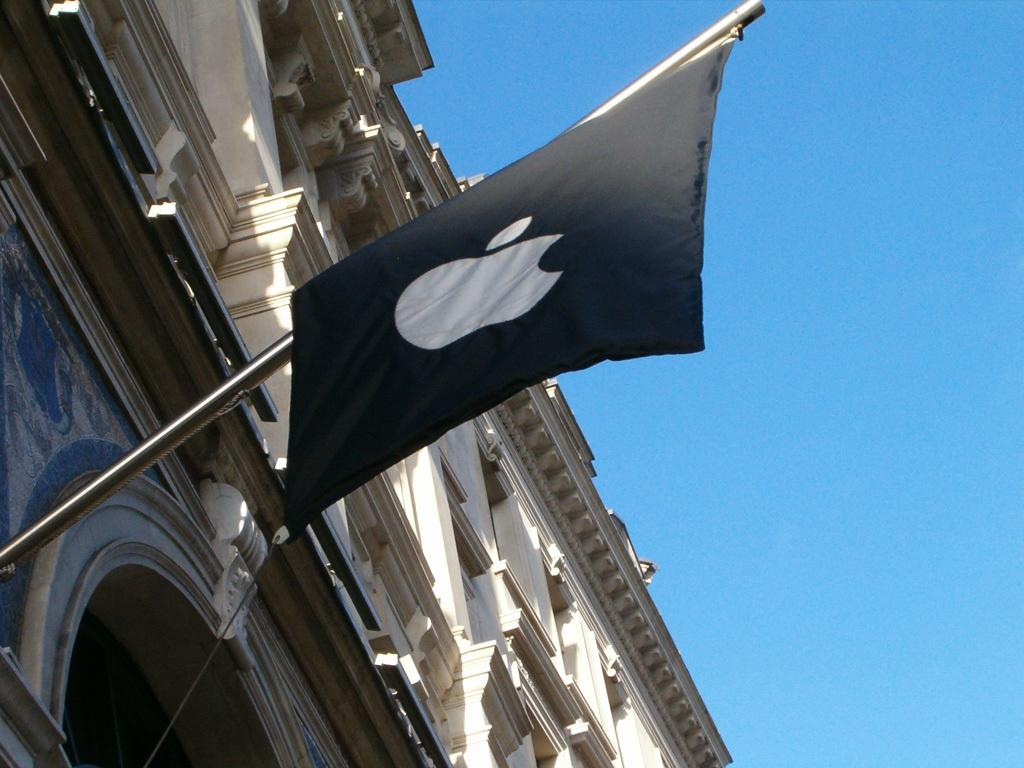What structure is located on the left side of the image? There is a building on the left side of the image. What can be seen on a pole in the image? There is a black color flag on a pole in the image. What is visible in the image besides the building and flag? The sky is visible in the image. What is the color of the sky in the image? The color of the sky is blue. Can you tell me how many people are talking near the building in the image? There is no information about people talking or any cups present in the image. Is there a playground visible in the image? There is no playground present in the image; it features a building and a black color flag on a pole. 